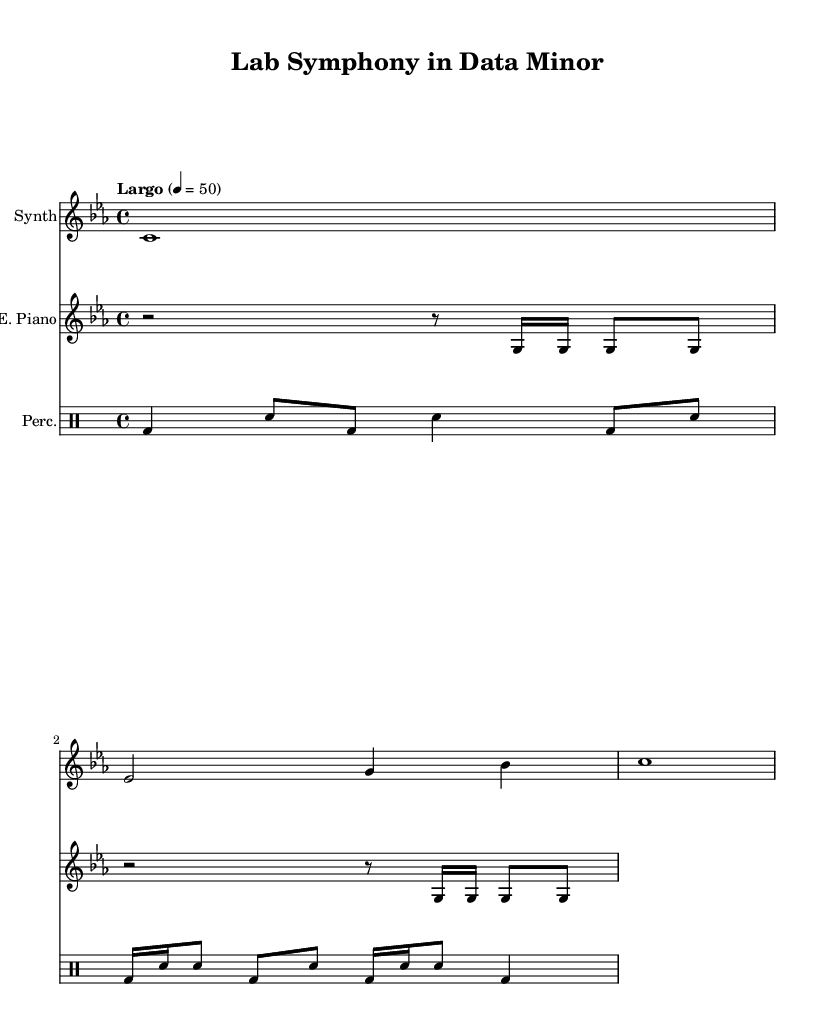What is the key signature of this music? The key signature is indicated by the "c" at the beginning of the global section and the absence of any sharps or flats. Therefore, it is C minor.
Answer: C minor What is the time signature of this piece? The time signature is shown as "4/4" in the global section, which means there are four beats in each measure.
Answer: 4/4 What is the tempo marking for the music? The tempo marking is "Largo" with a metronome setting of "4 = 50," indicating the speed at which the piece should be played.
Answer: Largo How many instruments are used in this composition? The score section shows three distinct "Staff" instruments: Synth, Electric Piano, and Percussion, suggesting that three instruments are used.
Answer: Three Which rhythmic element corresponds with the lab equipment sounds? The percussion part is designed to mimic various laboratory equipment sounds, using combinations of bass drums and snare hits, which are commonly associated with rhythmic experimental sounds.
Answer: Percussion What is the primary texture of this score? The score combines drone-like synths with rhythmic piano and percussion, creating an ambient texture. The layering and repeating motifs establish a textured soundscape reflecting the environment of a lab.
Answer: Ambient 